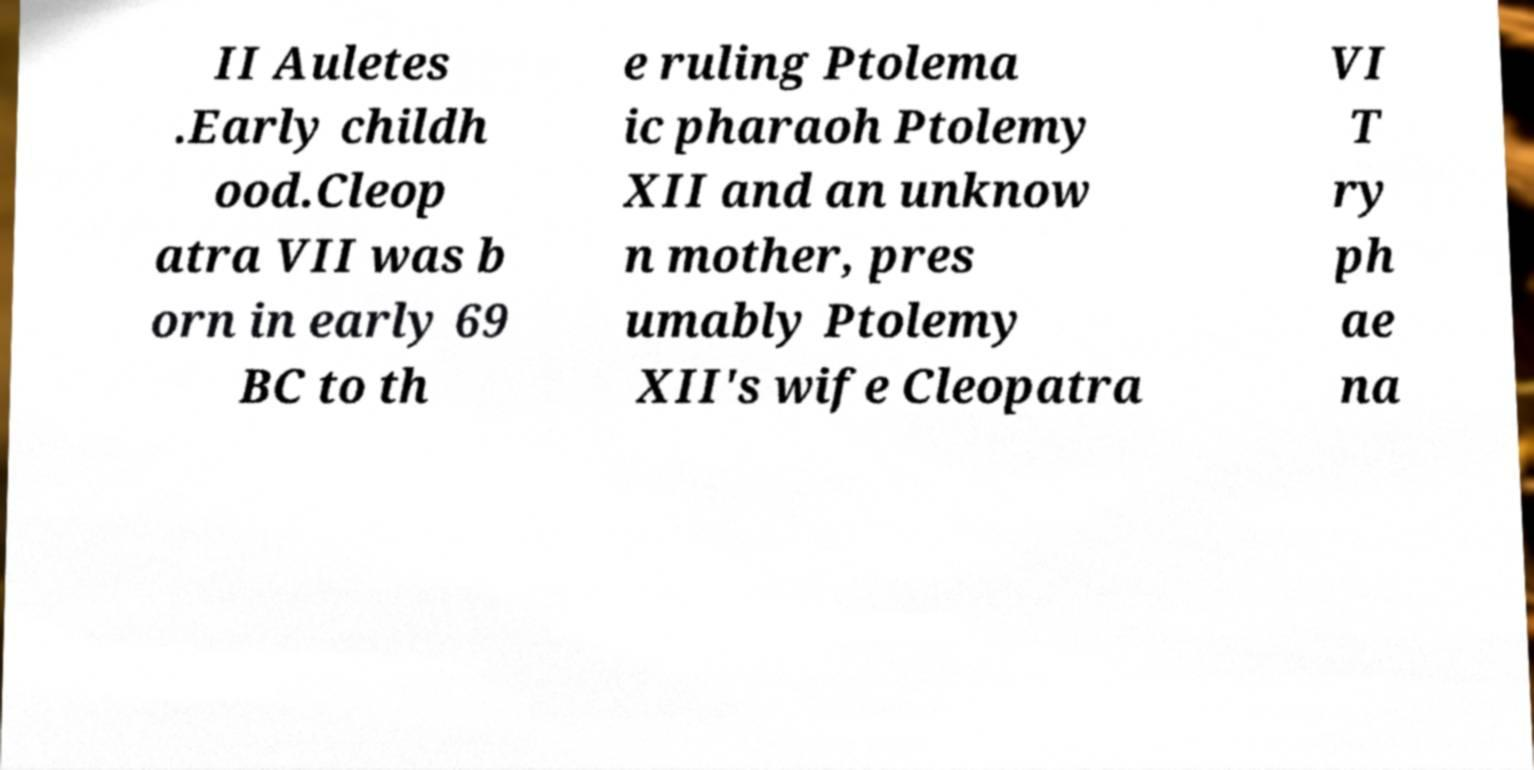There's text embedded in this image that I need extracted. Can you transcribe it verbatim? II Auletes .Early childh ood.Cleop atra VII was b orn in early 69 BC to th e ruling Ptolema ic pharaoh Ptolemy XII and an unknow n mother, pres umably Ptolemy XII's wife Cleopatra VI T ry ph ae na 